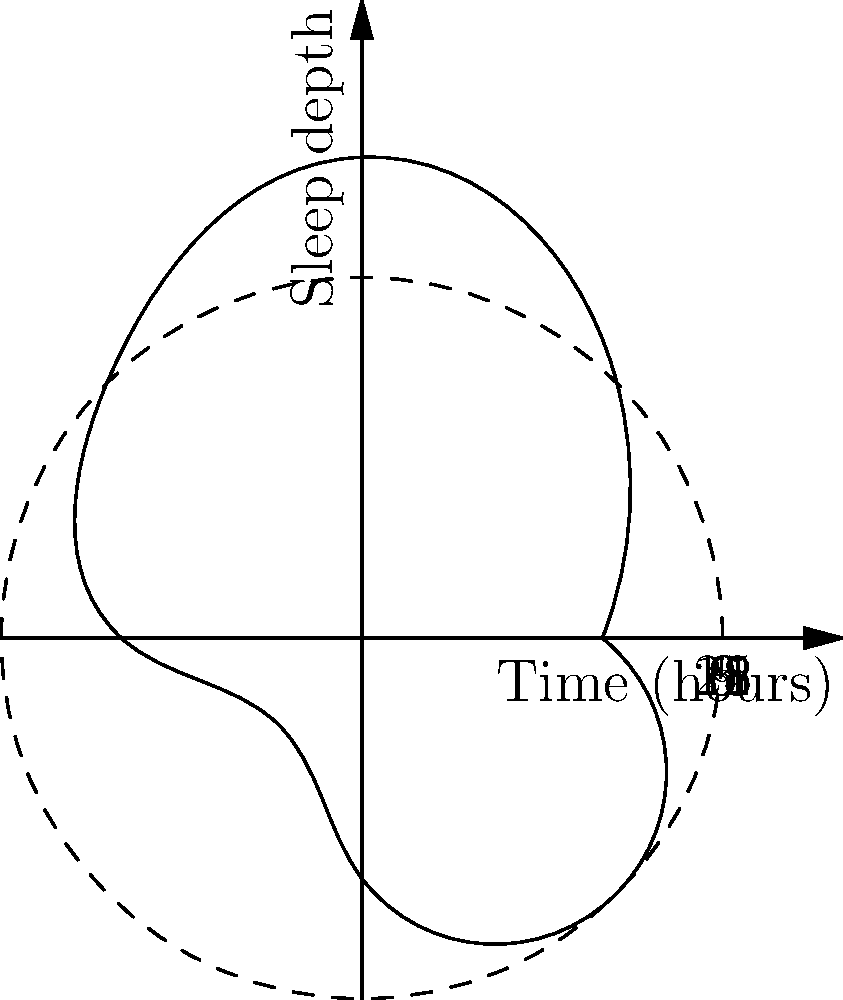In the polar coordinate plot representing a 24-hour sleep cycle, what is the approximate time (in hours) when the deepest sleep occurs? To determine the time of deepest sleep from the polar coordinate plot:

1. Understand the plot:
   - The angle represents time over a 24-hour period.
   - The radius represents sleep depth (larger radius = deeper sleep).

2. Identify the deepest sleep point:
   - This is the point furthest from the center of the circle.
   - In this plot, it occurs at approximately $\frac{\pi}{2}$ radians.

3. Convert radians to hours:
   - $2\pi$ radians = 24 hours
   - $\frac{\pi}{2}$ radians = $\frac{24}{4} = 6$ hours

4. Interpret the result:
   - 0 hours on the plot represents midnight (12 AM).
   - 6 hours after midnight is 6 AM.

Therefore, the deepest sleep occurs at approximately 6 AM according to this sleep cycle representation.
Answer: 6 AM 